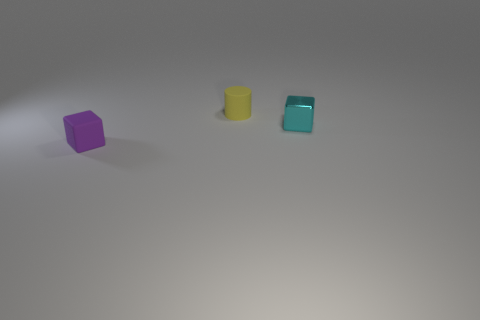Add 3 small gray things. How many objects exist? 6 Subtract all small metallic cubes. Subtract all small cyan blocks. How many objects are left? 1 Add 1 tiny yellow rubber objects. How many tiny yellow rubber objects are left? 2 Add 3 tiny yellow cylinders. How many tiny yellow cylinders exist? 4 Subtract 1 purple cubes. How many objects are left? 2 Subtract all cylinders. How many objects are left? 2 Subtract all brown cylinders. Subtract all cyan blocks. How many cylinders are left? 1 